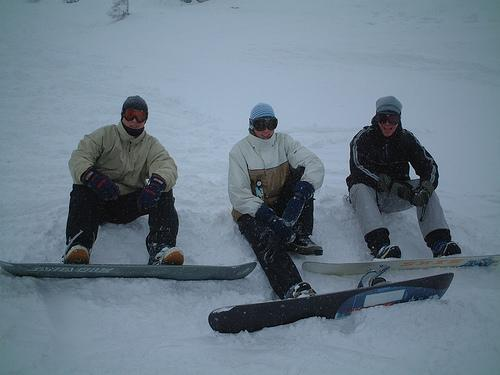Sitting like this allows the snowboarders to avoid doing what with their Snow boards? Please explain your reasoning. removing them. The snowboarder look like they are taking a short rest.  if they were not in this outstretched position, it would mean that they may have to remove them from their feet. 